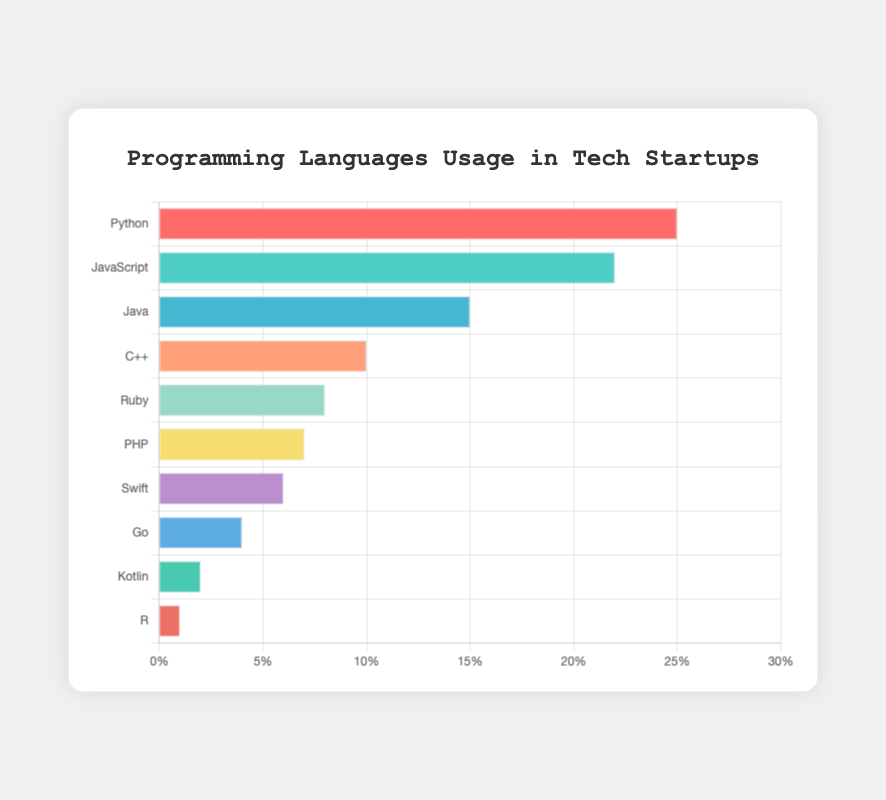What programming language has the highest usage percentage? By examining the horizontal bar chart, we look for the longest bar as it represents the highest value. Python has the longest bar, indicating it has the highest usage percentage.
Answer: Python Which programming language has the lowest usage percentage? We identify the shortest bar in the bar chart, which corresponds to the lowest value. The programming language with the shortest bar is R, indicating its usage percentage is the lowest.
Answer: R Which programming language usage is more popular, Java or JavaScript? We compare the bars corresponding to Java and JavaScript. JavaScript's bar is noticeably longer than Java's bar, indicating a higher usage percentage for JavaScript.
Answer: JavaScript How much greater is the usage percentage of Python compared to PHP? Locate the bars for Python and PHP. Python's usage percentage is 25%, and PHP's is 7%. Subtract PHP's percentage from Python's: 25% - 7% = 18%.
Answer: 18% What is the sum of the usage percentages of Ruby and Swift? Find the usage percentages of Ruby and Swift from the bar chart. Ruby has 8% and Swift has 6%. Add them together to get: 8% + 6% = 14%.
Answer: 14% What percentage of startups use languages other than Python, JavaScript, and Java? Sum the usage percentages of Python, JavaScript, and Java: 25% + 22% + 15% = 62%. Subtract from 100% to get the percentage that use other languages: 100% - 62% = 38%.
Answer: 38% Are there any programming languages with equal usage percentages? Examine the lengths of the bars. No two bars have the same length, indicating no programming languages have equal usage percentages.
Answer: No Which programming languages have a usage percentage between 5% and 10%? Identify the bars whose lengths correspond to values between 5% and 10%. C++, Ruby, PHP, and Swift fall into this range based on their bar lengths.
Answer: C++, Ruby, PHP, Swift 